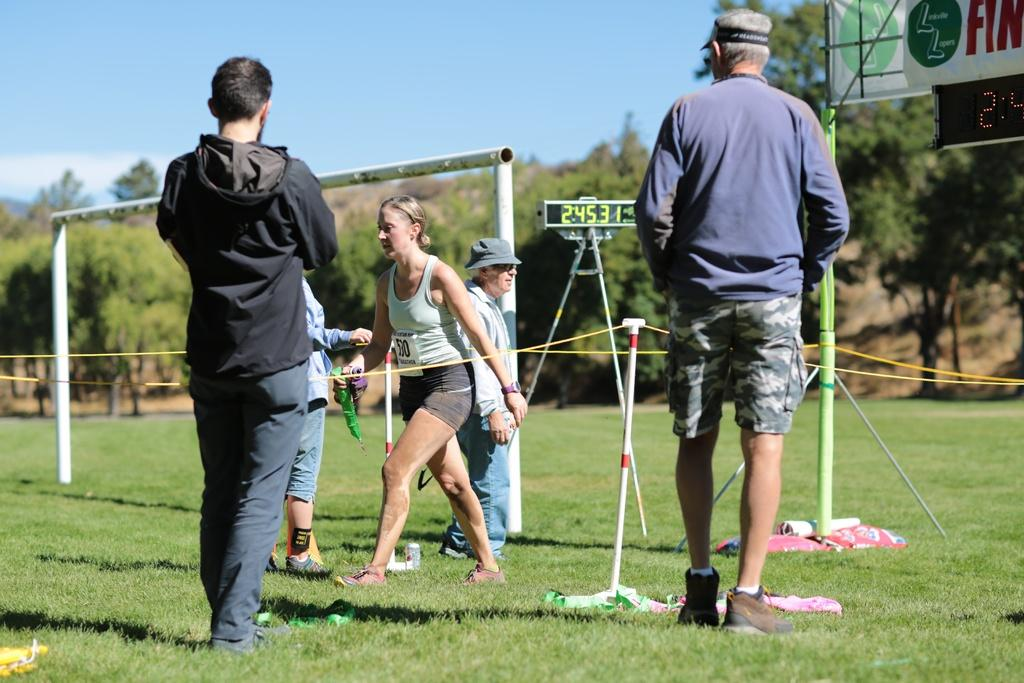<image>
Present a compact description of the photo's key features. An athlete with bib number 5:30 runs through the grass. 